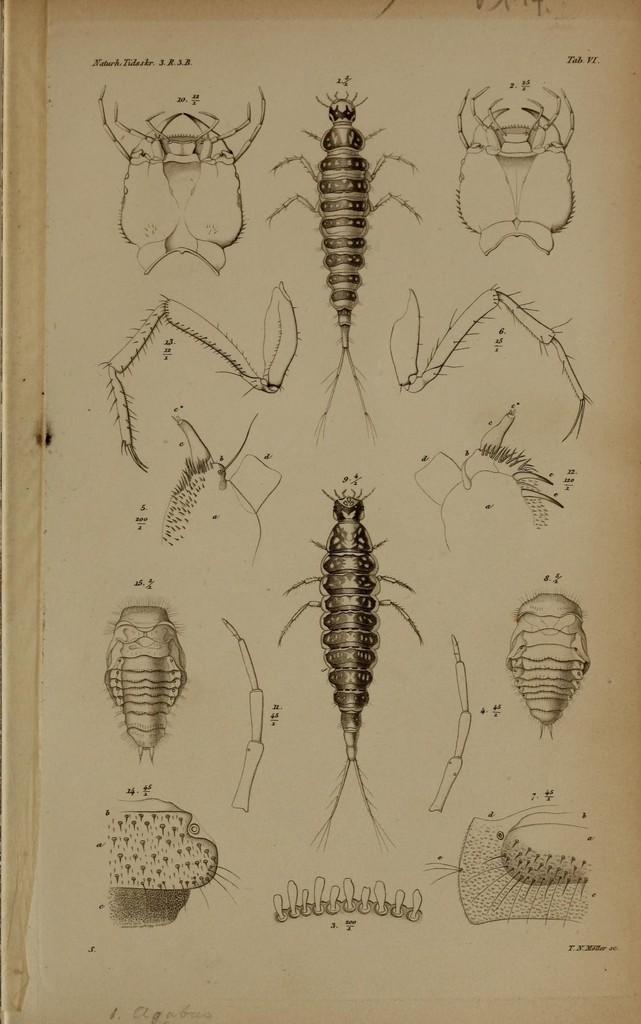How would you summarize this image in a sentence or two? In the picture we can see a chart with a diagram of the insect and its parts. 